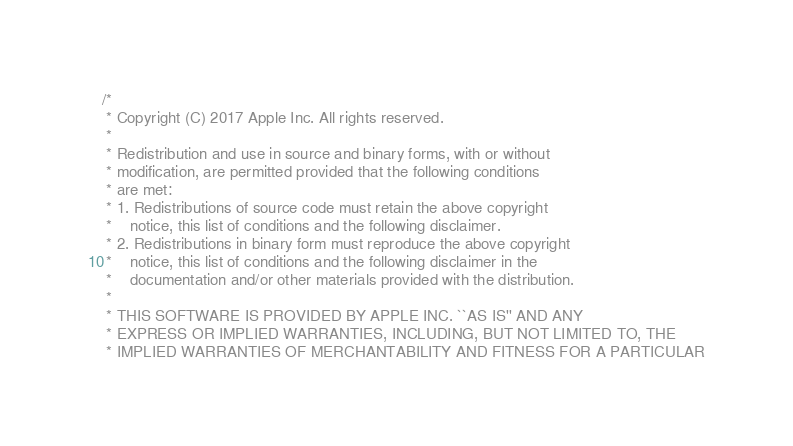<code> <loc_0><loc_0><loc_500><loc_500><_C_>/*
 * Copyright (C) 2017 Apple Inc. All rights reserved.
 *
 * Redistribution and use in source and binary forms, with or without
 * modification, are permitted provided that the following conditions
 * are met:
 * 1. Redistributions of source code must retain the above copyright
 *    notice, this list of conditions and the following disclaimer.
 * 2. Redistributions in binary form must reproduce the above copyright
 *    notice, this list of conditions and the following disclaimer in the
 *    documentation and/or other materials provided with the distribution.
 *
 * THIS SOFTWARE IS PROVIDED BY APPLE INC. ``AS IS'' AND ANY
 * EXPRESS OR IMPLIED WARRANTIES, INCLUDING, BUT NOT LIMITED TO, THE
 * IMPLIED WARRANTIES OF MERCHANTABILITY AND FITNESS FOR A PARTICULAR</code> 